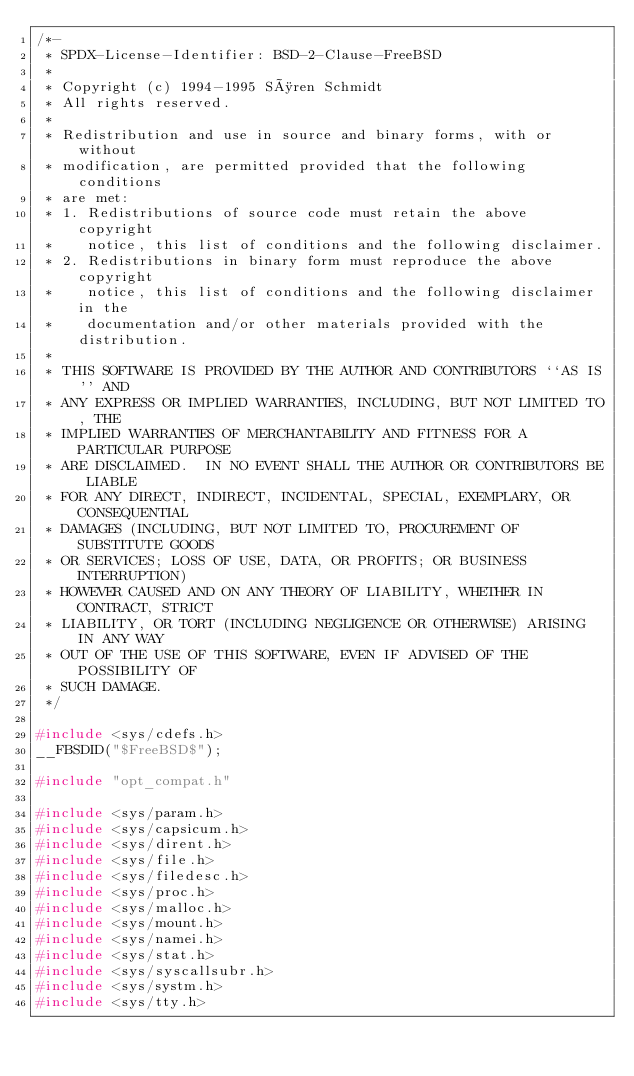Convert code to text. <code><loc_0><loc_0><loc_500><loc_500><_C_>/*-
 * SPDX-License-Identifier: BSD-2-Clause-FreeBSD
 *
 * Copyright (c) 1994-1995 Søren Schmidt
 * All rights reserved.
 *
 * Redistribution and use in source and binary forms, with or without
 * modification, are permitted provided that the following conditions
 * are met:
 * 1. Redistributions of source code must retain the above copyright
 *    notice, this list of conditions and the following disclaimer.
 * 2. Redistributions in binary form must reproduce the above copyright
 *    notice, this list of conditions and the following disclaimer in the
 *    documentation and/or other materials provided with the distribution.
 *
 * THIS SOFTWARE IS PROVIDED BY THE AUTHOR AND CONTRIBUTORS ``AS IS'' AND
 * ANY EXPRESS OR IMPLIED WARRANTIES, INCLUDING, BUT NOT LIMITED TO, THE
 * IMPLIED WARRANTIES OF MERCHANTABILITY AND FITNESS FOR A PARTICULAR PURPOSE
 * ARE DISCLAIMED.  IN NO EVENT SHALL THE AUTHOR OR CONTRIBUTORS BE LIABLE
 * FOR ANY DIRECT, INDIRECT, INCIDENTAL, SPECIAL, EXEMPLARY, OR CONSEQUENTIAL
 * DAMAGES (INCLUDING, BUT NOT LIMITED TO, PROCUREMENT OF SUBSTITUTE GOODS
 * OR SERVICES; LOSS OF USE, DATA, OR PROFITS; OR BUSINESS INTERRUPTION)
 * HOWEVER CAUSED AND ON ANY THEORY OF LIABILITY, WHETHER IN CONTRACT, STRICT
 * LIABILITY, OR TORT (INCLUDING NEGLIGENCE OR OTHERWISE) ARISING IN ANY WAY
 * OUT OF THE USE OF THIS SOFTWARE, EVEN IF ADVISED OF THE POSSIBILITY OF
 * SUCH DAMAGE.
 */

#include <sys/cdefs.h>
__FBSDID("$FreeBSD$");

#include "opt_compat.h"

#include <sys/param.h>
#include <sys/capsicum.h>
#include <sys/dirent.h>
#include <sys/file.h>
#include <sys/filedesc.h>
#include <sys/proc.h>
#include <sys/malloc.h>
#include <sys/mount.h>
#include <sys/namei.h>
#include <sys/stat.h>
#include <sys/syscallsubr.h>
#include <sys/systm.h>
#include <sys/tty.h></code> 